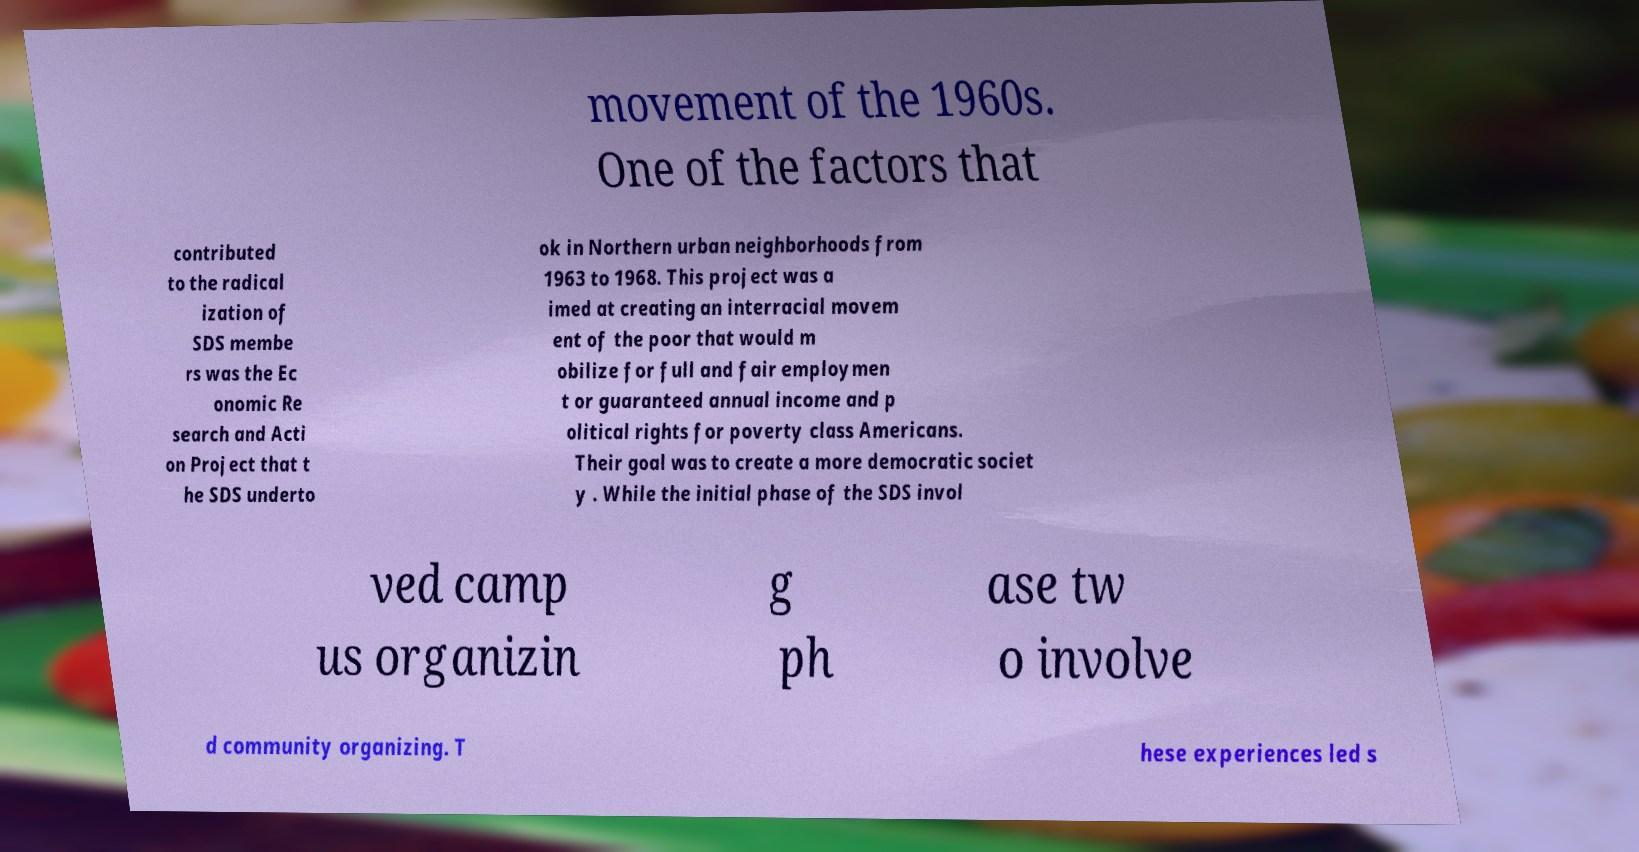There's text embedded in this image that I need extracted. Can you transcribe it verbatim? movement of the 1960s. One of the factors that contributed to the radical ization of SDS membe rs was the Ec onomic Re search and Acti on Project that t he SDS underto ok in Northern urban neighborhoods from 1963 to 1968. This project was a imed at creating an interracial movem ent of the poor that would m obilize for full and fair employmen t or guaranteed annual income and p olitical rights for poverty class Americans. Their goal was to create a more democratic societ y . While the initial phase of the SDS invol ved camp us organizin g ph ase tw o involve d community organizing. T hese experiences led s 